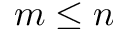<formula> <loc_0><loc_0><loc_500><loc_500>m \leq n</formula> 